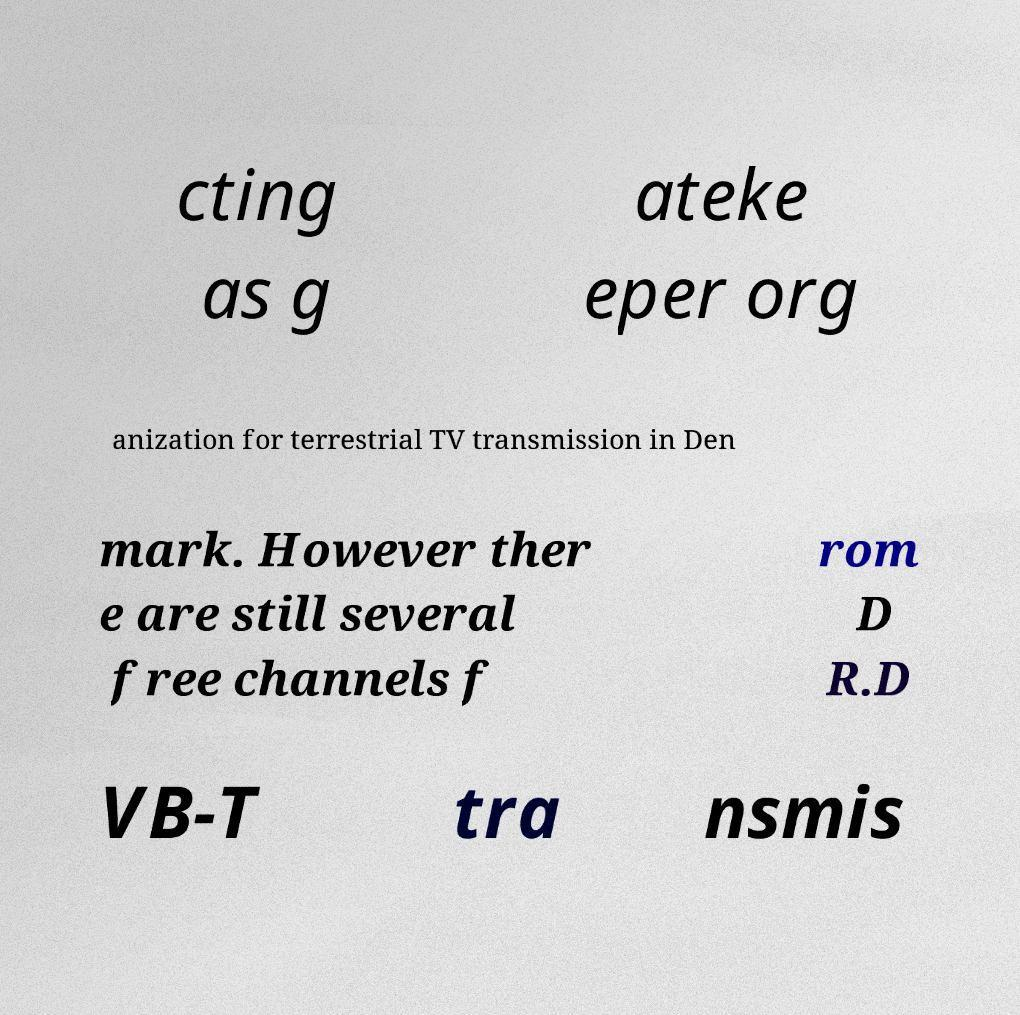I need the written content from this picture converted into text. Can you do that? cting as g ateke eper org anization for terrestrial TV transmission in Den mark. However ther e are still several free channels f rom D R.D VB-T tra nsmis 